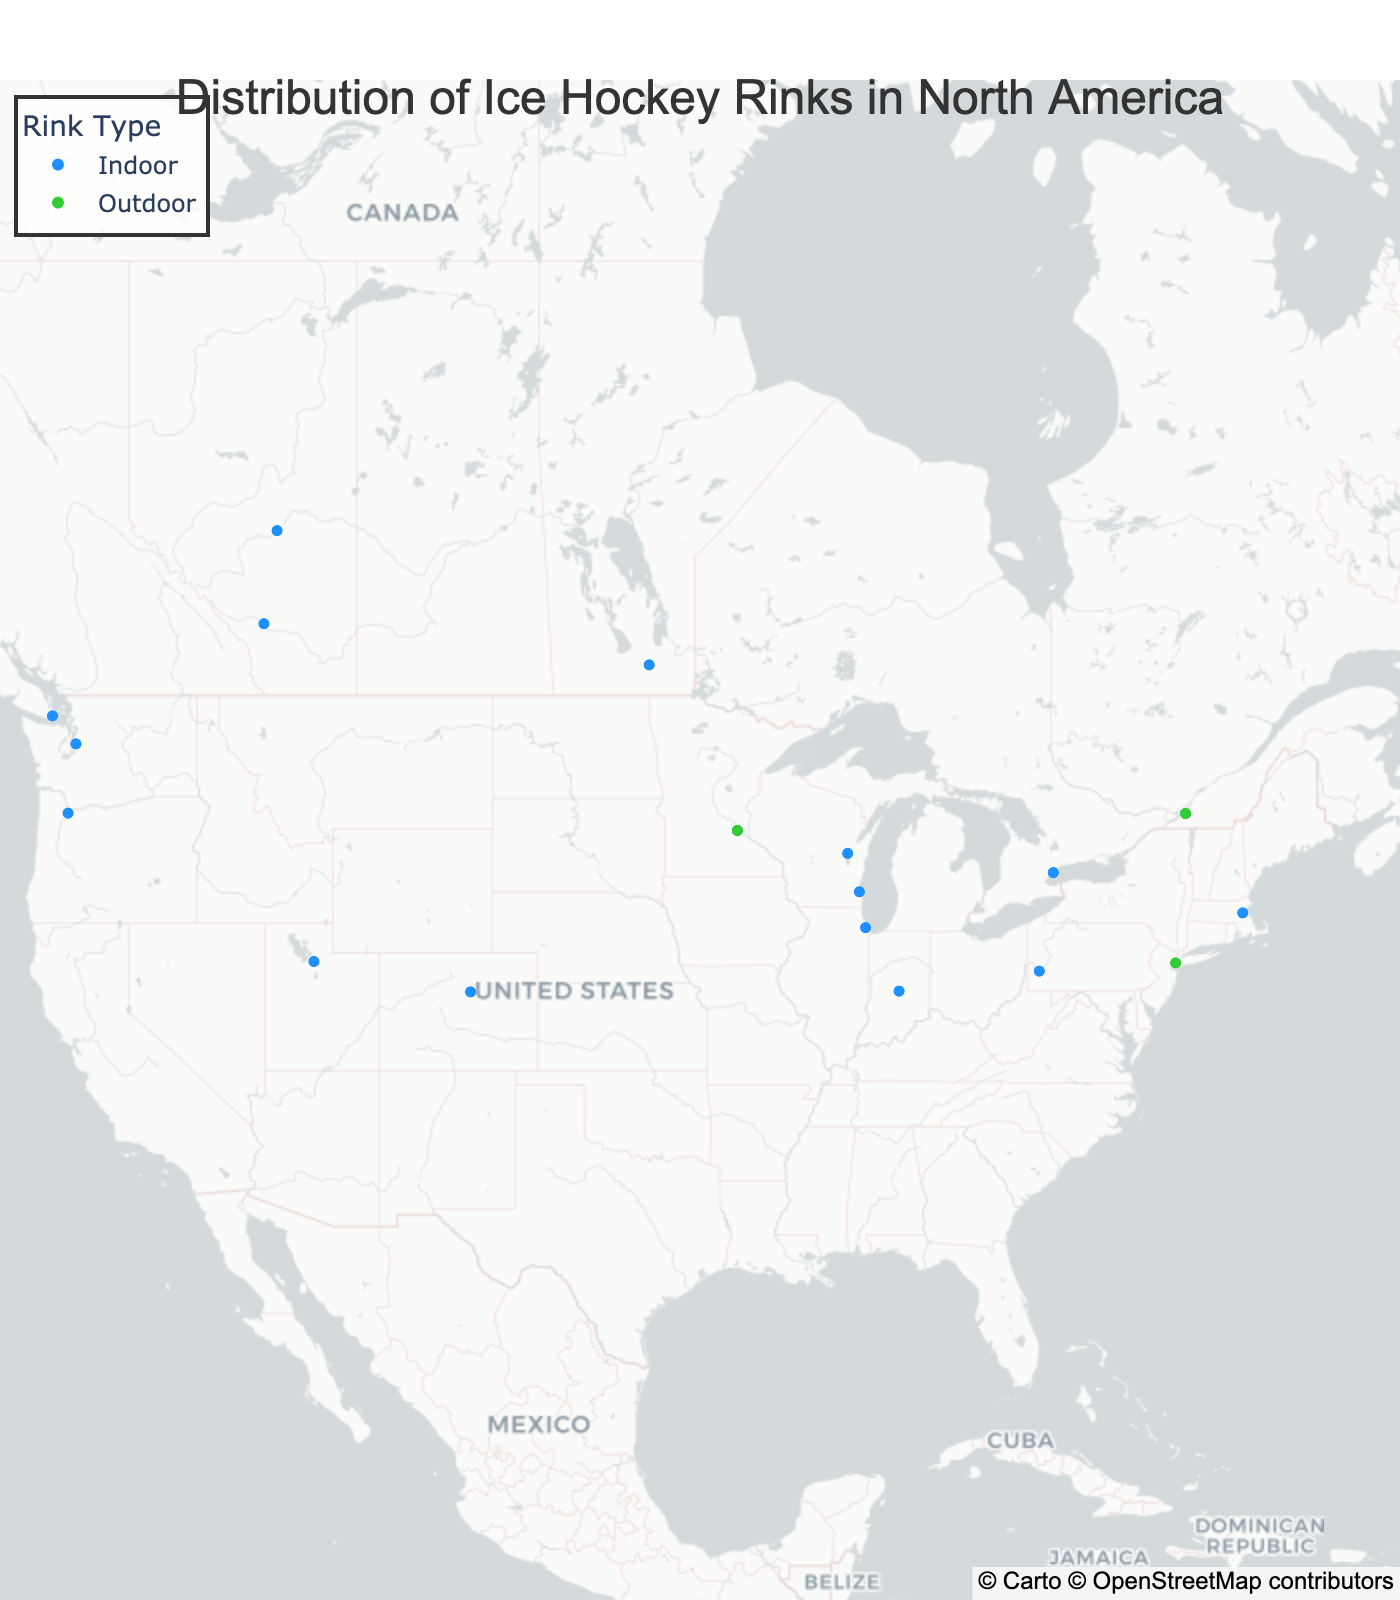What's the title of the figure? The title is located at the top of the figure and it summarizes the main subject of the visualization.
Answer: Distribution of Ice Hockey Rinks in North America How many outdoor ice hockey rinks are displayed in the figure? By visually scanning the plotted points, we observe that there are three 'Outdoor' type rinks indicated by the green color.
Answer: 3 Which city has the highest number of ice hockey rinks displayed in the figure? The hover information shows that Minneapolis has two rinks: 'Mariucci Arena' (Indoor) and 'Parade Ice Garden' (Outdoor). This is more than any other city.
Answer: Minneapolis How many ice hockey rinks are located in Canada? Inspect the hover data of each point and count the number of rinks with the 'Country' field set to 'Canada'. There are eight: Scotiabank Saddledome, Bell Centre, Scotiabank Arena, Canada Life Centre, Rexall Place, Save-On-Foods Memorial Centre, Beaver Lake, and Magness Arena.
Answer: 8 Are there more indoor or outdoor rinks in North America according to the figure? By counting the number of points with hover data 'Type' as 'Indoor' and 'Outdoor', we observe that there are 16 indoor and 3 outdoor rinks.
Answer: Indoor Which city has both an indoor and an outdoor ice hockey rink? By comparing the city names in the hover data, we find that Minneapolis is the only city listed multiple times with both an indoor and an outdoor rink.
Answer: Minneapolis How are the ice hockey rinks distributed geographically in North America? The plotted points show a higher density of ice hockey rinks in the northern parts of the USA and Canada, especially in larger cities such as Calgary, Toronto, and Montreal, indicating a concentration in these areas.
Answer: Mostly in northern USA and Canada, especially larger cities Which rink type is more evenly distributed across North America? By observing the spread of the colors representing rink types, outdoor rinks appear sparse and localized (3 points) while indoor rinks are more widely distributed across both the USA and Canada (16 points).
Answer: Indoor 